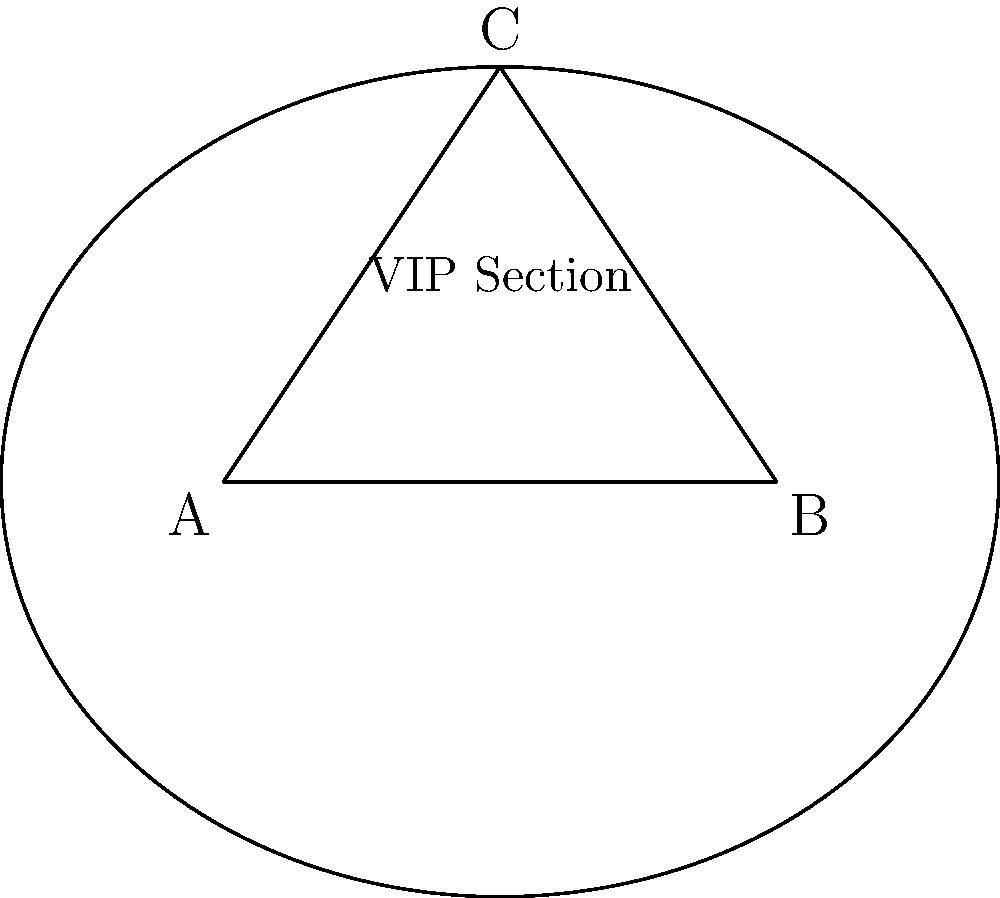As the press officer for a high-profile gala event, you're tasked with maximizing the VIP section's area. The event space is triangular, with corners at A(0,0), B(8,0), and C(4,6). To add a touch of sophistication, you decide to use a conic section for the VIP area. Which conic section will provide the largest possible area within the triangular space, and what is its area? To maximize the area within a triangle using a conic section, we should use an ellipse. Here's why:

1. The ellipse is the only conic section that can be fully contained within a triangle while touching all three sides.

2. The maximum area ellipse inscribed in a triangle is known as the Steiner inellipse.

3. For any triangle, the area of its Steiner inellipse is exactly $\frac{\pi}{3}$ times the area of the triangle.

Let's solve this step-by-step:

1. Calculate the area of the triangular event space:
   Area of triangle = $\frac{1}{2} \times base \times height$
   $A_{triangle} = \frac{1}{2} \times 8 \times 6 = 24$ square units

2. Calculate the area of the Steiner inellipse:
   $A_{ellipse} = \frac{\pi}{3} \times A_{triangle}$
   $A_{ellipse} = \frac{\pi}{3} \times 24 = 8\pi$ square units

Therefore, the largest possible area for the VIP section using a conic section is $8\pi$ square units, achieved by using an ellipse.
Answer: Ellipse with area $8\pi$ square units 